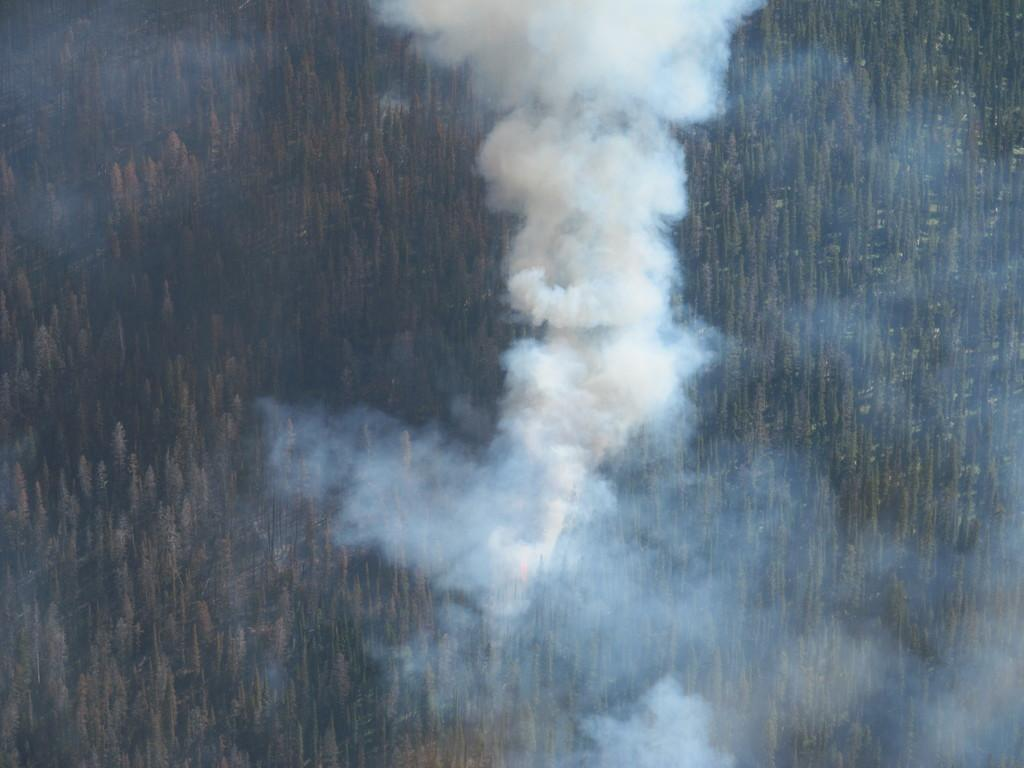What can be seen in the image that indicates some sort of activity or event? There is smoke in the image, which suggests that something is burning or producing smoke. What type of natural elements are present in the image? There are a couple of trees in the image, which are examples of natural elements. How many toes can be seen on the trees in the image? Trees do not have toes, so this question is not applicable to the image. 